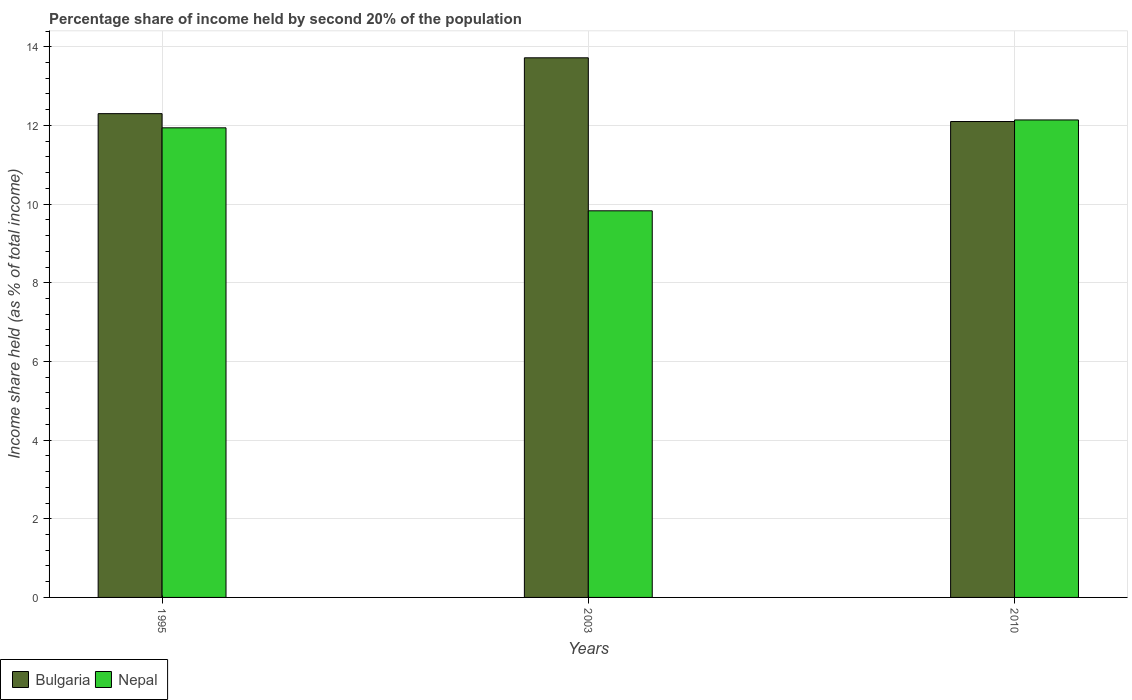How many different coloured bars are there?
Offer a very short reply. 2. How many groups of bars are there?
Provide a succinct answer. 3. Are the number of bars on each tick of the X-axis equal?
Ensure brevity in your answer.  Yes. How many bars are there on the 3rd tick from the left?
Your response must be concise. 2. What is the share of income held by second 20% of the population in Bulgaria in 2003?
Your response must be concise. 13.72. Across all years, what is the maximum share of income held by second 20% of the population in Bulgaria?
Offer a very short reply. 13.72. Across all years, what is the minimum share of income held by second 20% of the population in Nepal?
Give a very brief answer. 9.83. What is the total share of income held by second 20% of the population in Nepal in the graph?
Provide a short and direct response. 33.91. What is the difference between the share of income held by second 20% of the population in Bulgaria in 1995 and that in 2010?
Give a very brief answer. 0.2. What is the difference between the share of income held by second 20% of the population in Bulgaria in 2003 and the share of income held by second 20% of the population in Nepal in 1995?
Provide a succinct answer. 1.78. What is the average share of income held by second 20% of the population in Nepal per year?
Offer a terse response. 11.3. In the year 2010, what is the difference between the share of income held by second 20% of the population in Nepal and share of income held by second 20% of the population in Bulgaria?
Offer a very short reply. 0.04. In how many years, is the share of income held by second 20% of the population in Nepal greater than 13.2 %?
Your answer should be very brief. 0. What is the ratio of the share of income held by second 20% of the population in Bulgaria in 2003 to that in 2010?
Keep it short and to the point. 1.13. What is the difference between the highest and the second highest share of income held by second 20% of the population in Nepal?
Ensure brevity in your answer.  0.2. What is the difference between the highest and the lowest share of income held by second 20% of the population in Nepal?
Your answer should be compact. 2.31. What does the 2nd bar from the left in 2003 represents?
Your response must be concise. Nepal. What does the 2nd bar from the right in 2010 represents?
Keep it short and to the point. Bulgaria. How many years are there in the graph?
Provide a succinct answer. 3. What is the difference between two consecutive major ticks on the Y-axis?
Your answer should be compact. 2. Are the values on the major ticks of Y-axis written in scientific E-notation?
Keep it short and to the point. No. Does the graph contain any zero values?
Provide a succinct answer. No. Does the graph contain grids?
Your response must be concise. Yes. What is the title of the graph?
Provide a short and direct response. Percentage share of income held by second 20% of the population. What is the label or title of the X-axis?
Offer a terse response. Years. What is the label or title of the Y-axis?
Your answer should be compact. Income share held (as % of total income). What is the Income share held (as % of total income) of Bulgaria in 1995?
Offer a very short reply. 12.3. What is the Income share held (as % of total income) of Nepal in 1995?
Your answer should be very brief. 11.94. What is the Income share held (as % of total income) of Bulgaria in 2003?
Provide a short and direct response. 13.72. What is the Income share held (as % of total income) of Nepal in 2003?
Make the answer very short. 9.83. What is the Income share held (as % of total income) in Nepal in 2010?
Offer a very short reply. 12.14. Across all years, what is the maximum Income share held (as % of total income) of Bulgaria?
Provide a short and direct response. 13.72. Across all years, what is the maximum Income share held (as % of total income) of Nepal?
Provide a short and direct response. 12.14. Across all years, what is the minimum Income share held (as % of total income) of Nepal?
Provide a short and direct response. 9.83. What is the total Income share held (as % of total income) in Bulgaria in the graph?
Make the answer very short. 38.12. What is the total Income share held (as % of total income) in Nepal in the graph?
Make the answer very short. 33.91. What is the difference between the Income share held (as % of total income) in Bulgaria in 1995 and that in 2003?
Make the answer very short. -1.42. What is the difference between the Income share held (as % of total income) in Nepal in 1995 and that in 2003?
Make the answer very short. 2.11. What is the difference between the Income share held (as % of total income) in Nepal in 1995 and that in 2010?
Give a very brief answer. -0.2. What is the difference between the Income share held (as % of total income) of Bulgaria in 2003 and that in 2010?
Your answer should be compact. 1.62. What is the difference between the Income share held (as % of total income) in Nepal in 2003 and that in 2010?
Offer a terse response. -2.31. What is the difference between the Income share held (as % of total income) in Bulgaria in 1995 and the Income share held (as % of total income) in Nepal in 2003?
Keep it short and to the point. 2.47. What is the difference between the Income share held (as % of total income) of Bulgaria in 1995 and the Income share held (as % of total income) of Nepal in 2010?
Offer a very short reply. 0.16. What is the difference between the Income share held (as % of total income) of Bulgaria in 2003 and the Income share held (as % of total income) of Nepal in 2010?
Offer a very short reply. 1.58. What is the average Income share held (as % of total income) of Bulgaria per year?
Provide a succinct answer. 12.71. What is the average Income share held (as % of total income) of Nepal per year?
Your answer should be compact. 11.3. In the year 1995, what is the difference between the Income share held (as % of total income) in Bulgaria and Income share held (as % of total income) in Nepal?
Ensure brevity in your answer.  0.36. In the year 2003, what is the difference between the Income share held (as % of total income) of Bulgaria and Income share held (as % of total income) of Nepal?
Your answer should be very brief. 3.89. In the year 2010, what is the difference between the Income share held (as % of total income) of Bulgaria and Income share held (as % of total income) of Nepal?
Ensure brevity in your answer.  -0.04. What is the ratio of the Income share held (as % of total income) of Bulgaria in 1995 to that in 2003?
Offer a very short reply. 0.9. What is the ratio of the Income share held (as % of total income) in Nepal in 1995 to that in 2003?
Your answer should be compact. 1.21. What is the ratio of the Income share held (as % of total income) in Bulgaria in 1995 to that in 2010?
Keep it short and to the point. 1.02. What is the ratio of the Income share held (as % of total income) of Nepal in 1995 to that in 2010?
Provide a short and direct response. 0.98. What is the ratio of the Income share held (as % of total income) in Bulgaria in 2003 to that in 2010?
Your response must be concise. 1.13. What is the ratio of the Income share held (as % of total income) of Nepal in 2003 to that in 2010?
Keep it short and to the point. 0.81. What is the difference between the highest and the second highest Income share held (as % of total income) of Bulgaria?
Your response must be concise. 1.42. What is the difference between the highest and the second highest Income share held (as % of total income) in Nepal?
Ensure brevity in your answer.  0.2. What is the difference between the highest and the lowest Income share held (as % of total income) in Bulgaria?
Your answer should be compact. 1.62. What is the difference between the highest and the lowest Income share held (as % of total income) of Nepal?
Provide a succinct answer. 2.31. 